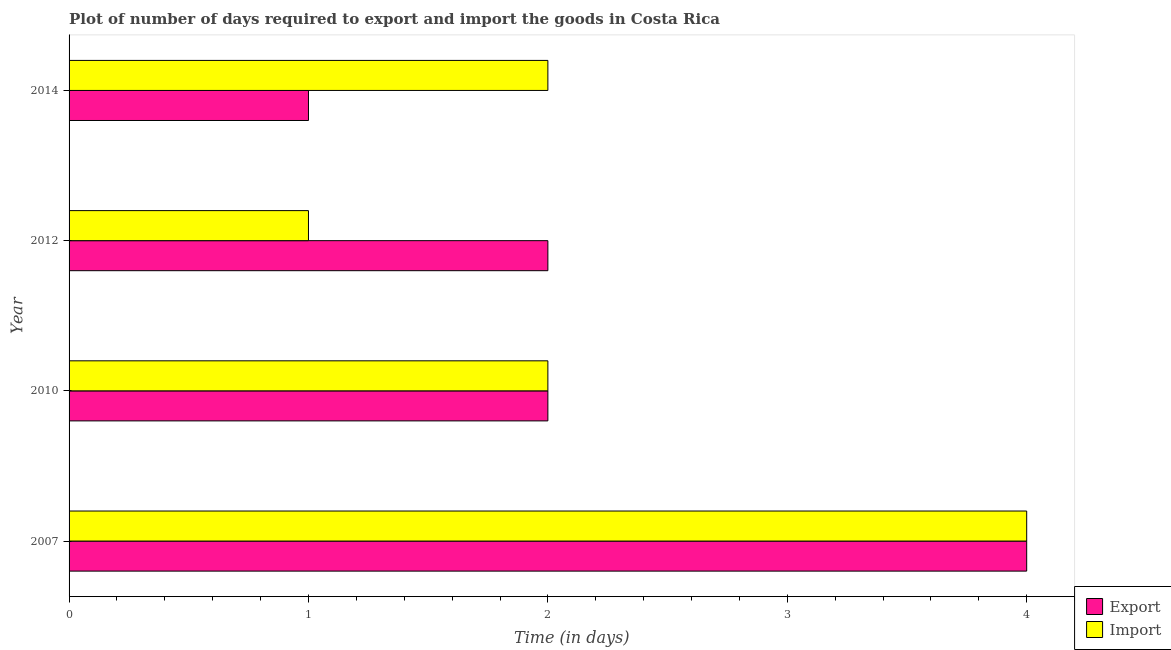How many different coloured bars are there?
Your response must be concise. 2. How many groups of bars are there?
Provide a short and direct response. 4. How many bars are there on the 4th tick from the top?
Provide a short and direct response. 2. What is the label of the 4th group of bars from the top?
Your answer should be very brief. 2007. In how many cases, is the number of bars for a given year not equal to the number of legend labels?
Offer a very short reply. 0. What is the time required to import in 2014?
Ensure brevity in your answer.  2. Across all years, what is the maximum time required to import?
Your response must be concise. 4. Across all years, what is the minimum time required to export?
Ensure brevity in your answer.  1. What is the total time required to export in the graph?
Your answer should be compact. 9. What is the difference between the time required to export in 2007 and that in 2010?
Provide a succinct answer. 2. What is the difference between the time required to export in 2007 and the time required to import in 2012?
Keep it short and to the point. 3. What is the average time required to import per year?
Offer a terse response. 2.25. In the year 2014, what is the difference between the time required to import and time required to export?
Offer a terse response. 1. What is the ratio of the time required to import in 2010 to that in 2014?
Make the answer very short. 1. Is the time required to export in 2012 less than that in 2014?
Your answer should be compact. No. What is the difference between the highest and the lowest time required to export?
Your response must be concise. 3. What does the 2nd bar from the top in 2012 represents?
Provide a succinct answer. Export. What does the 1st bar from the bottom in 2014 represents?
Your answer should be compact. Export. How many bars are there?
Your response must be concise. 8. Are all the bars in the graph horizontal?
Keep it short and to the point. Yes. How many years are there in the graph?
Make the answer very short. 4. What is the difference between two consecutive major ticks on the X-axis?
Give a very brief answer. 1. Are the values on the major ticks of X-axis written in scientific E-notation?
Give a very brief answer. No. Does the graph contain grids?
Provide a short and direct response. No. Where does the legend appear in the graph?
Offer a very short reply. Bottom right. How many legend labels are there?
Your response must be concise. 2. How are the legend labels stacked?
Provide a short and direct response. Vertical. What is the title of the graph?
Your answer should be compact. Plot of number of days required to export and import the goods in Costa Rica. What is the label or title of the X-axis?
Keep it short and to the point. Time (in days). What is the label or title of the Y-axis?
Offer a terse response. Year. What is the Time (in days) in Import in 2007?
Offer a very short reply. 4. What is the Time (in days) in Export in 2012?
Offer a very short reply. 2. What is the Time (in days) of Import in 2012?
Make the answer very short. 1. What is the Time (in days) of Export in 2014?
Provide a short and direct response. 1. Across all years, what is the maximum Time (in days) in Export?
Keep it short and to the point. 4. What is the total Time (in days) in Export in the graph?
Keep it short and to the point. 9. What is the total Time (in days) in Import in the graph?
Offer a very short reply. 9. What is the difference between the Time (in days) of Import in 2007 and that in 2012?
Ensure brevity in your answer.  3. What is the difference between the Time (in days) in Export in 2007 and that in 2014?
Your answer should be compact. 3. What is the difference between the Time (in days) in Import in 2007 and that in 2014?
Offer a very short reply. 2. What is the difference between the Time (in days) in Export in 2010 and that in 2012?
Your answer should be very brief. 0. What is the difference between the Time (in days) in Import in 2010 and that in 2014?
Ensure brevity in your answer.  0. What is the difference between the Time (in days) of Export in 2012 and that in 2014?
Your response must be concise. 1. What is the difference between the Time (in days) in Export in 2007 and the Time (in days) in Import in 2010?
Your response must be concise. 2. What is the difference between the Time (in days) in Export in 2007 and the Time (in days) in Import in 2014?
Offer a terse response. 2. What is the difference between the Time (in days) in Export in 2010 and the Time (in days) in Import in 2012?
Your answer should be compact. 1. What is the difference between the Time (in days) of Export in 2012 and the Time (in days) of Import in 2014?
Your answer should be compact. 0. What is the average Time (in days) in Export per year?
Your response must be concise. 2.25. What is the average Time (in days) of Import per year?
Your response must be concise. 2.25. In the year 2007, what is the difference between the Time (in days) in Export and Time (in days) in Import?
Offer a terse response. 0. In the year 2010, what is the difference between the Time (in days) of Export and Time (in days) of Import?
Your answer should be very brief. 0. In the year 2014, what is the difference between the Time (in days) in Export and Time (in days) in Import?
Provide a short and direct response. -1. What is the ratio of the Time (in days) in Export in 2007 to that in 2012?
Offer a very short reply. 2. What is the ratio of the Time (in days) in Export in 2007 to that in 2014?
Your answer should be compact. 4. What is the ratio of the Time (in days) in Export in 2010 to that in 2012?
Provide a short and direct response. 1. What is the ratio of the Time (in days) in Import in 2010 to that in 2012?
Ensure brevity in your answer.  2. What is the ratio of the Time (in days) in Export in 2010 to that in 2014?
Keep it short and to the point. 2. What is the ratio of the Time (in days) in Export in 2012 to that in 2014?
Offer a terse response. 2. What is the difference between the highest and the second highest Time (in days) of Export?
Make the answer very short. 2. What is the difference between the highest and the second highest Time (in days) in Import?
Give a very brief answer. 2. 